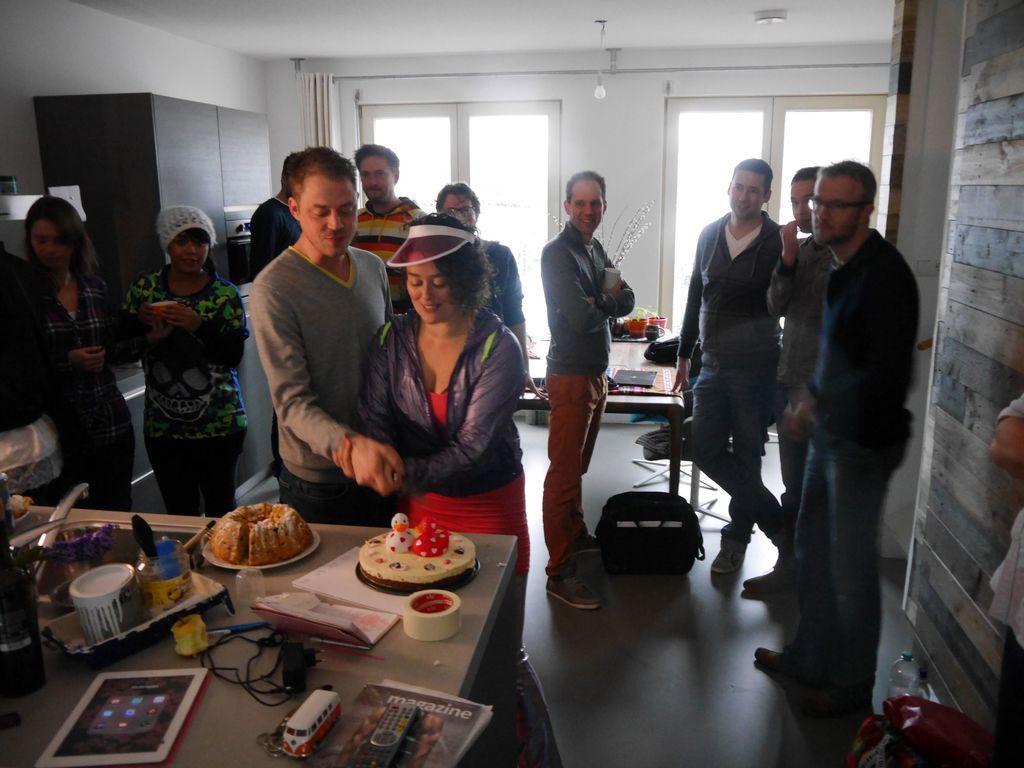Describe this image in one or two sentences. In this image there are group of persons who are standing in a room at the foreground of the image there are two persons who are cutting the cake. 